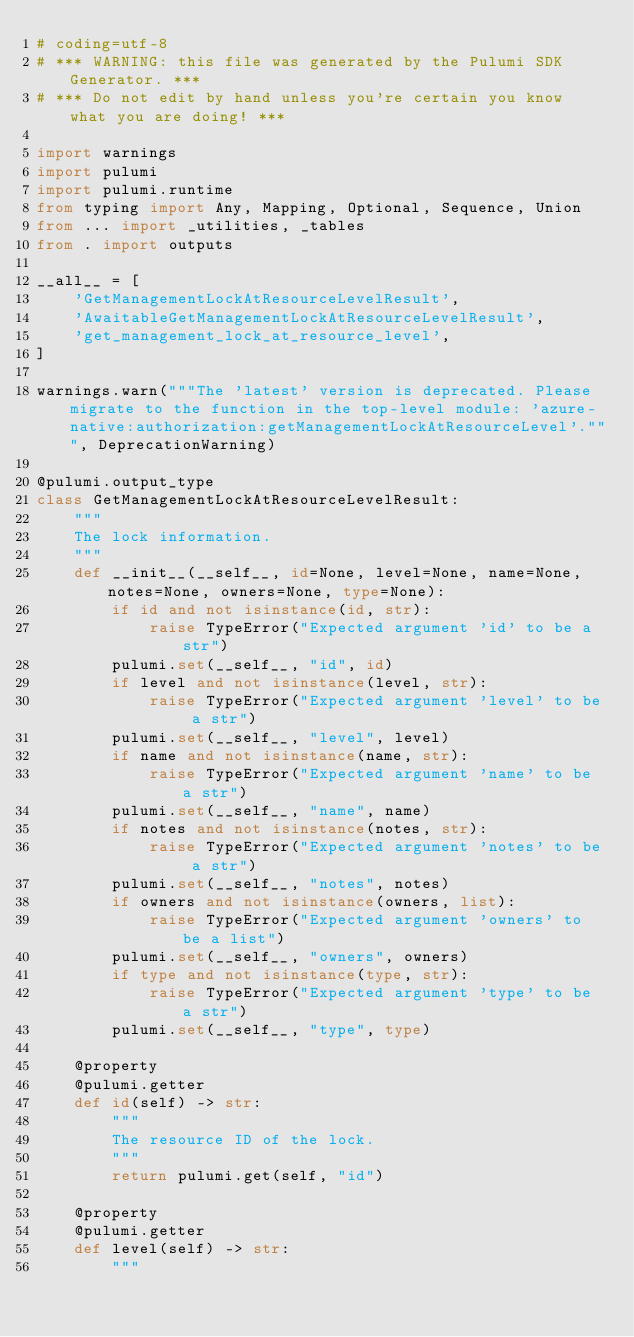Convert code to text. <code><loc_0><loc_0><loc_500><loc_500><_Python_># coding=utf-8
# *** WARNING: this file was generated by the Pulumi SDK Generator. ***
# *** Do not edit by hand unless you're certain you know what you are doing! ***

import warnings
import pulumi
import pulumi.runtime
from typing import Any, Mapping, Optional, Sequence, Union
from ... import _utilities, _tables
from . import outputs

__all__ = [
    'GetManagementLockAtResourceLevelResult',
    'AwaitableGetManagementLockAtResourceLevelResult',
    'get_management_lock_at_resource_level',
]

warnings.warn("""The 'latest' version is deprecated. Please migrate to the function in the top-level module: 'azure-native:authorization:getManagementLockAtResourceLevel'.""", DeprecationWarning)

@pulumi.output_type
class GetManagementLockAtResourceLevelResult:
    """
    The lock information.
    """
    def __init__(__self__, id=None, level=None, name=None, notes=None, owners=None, type=None):
        if id and not isinstance(id, str):
            raise TypeError("Expected argument 'id' to be a str")
        pulumi.set(__self__, "id", id)
        if level and not isinstance(level, str):
            raise TypeError("Expected argument 'level' to be a str")
        pulumi.set(__self__, "level", level)
        if name and not isinstance(name, str):
            raise TypeError("Expected argument 'name' to be a str")
        pulumi.set(__self__, "name", name)
        if notes and not isinstance(notes, str):
            raise TypeError("Expected argument 'notes' to be a str")
        pulumi.set(__self__, "notes", notes)
        if owners and not isinstance(owners, list):
            raise TypeError("Expected argument 'owners' to be a list")
        pulumi.set(__self__, "owners", owners)
        if type and not isinstance(type, str):
            raise TypeError("Expected argument 'type' to be a str")
        pulumi.set(__self__, "type", type)

    @property
    @pulumi.getter
    def id(self) -> str:
        """
        The resource ID of the lock.
        """
        return pulumi.get(self, "id")

    @property
    @pulumi.getter
    def level(self) -> str:
        """</code> 